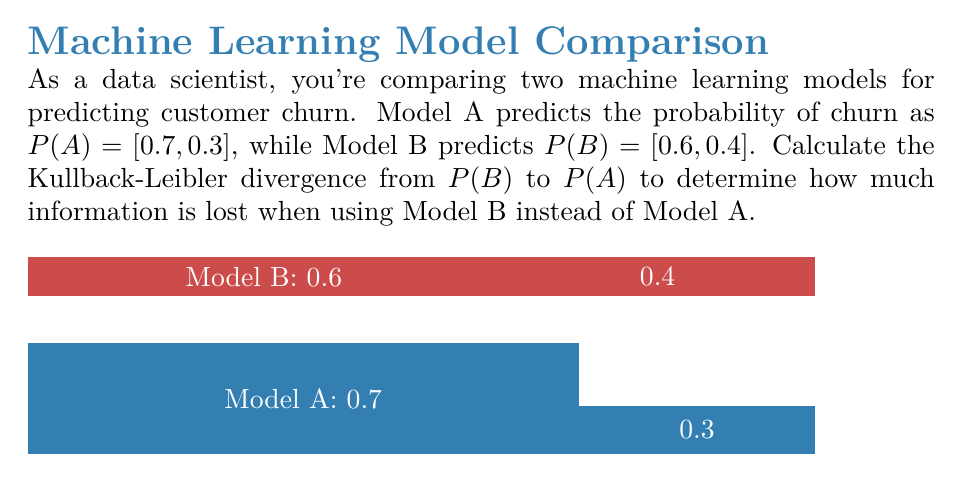Provide a solution to this math problem. To calculate the Kullback-Leibler (KL) divergence from P(B) to P(A), we'll use the formula:

$$ D_{KL}(P(A) || P(B)) = \sum_{i} P(A)_i \log(\frac{P(A)_i}{P(B)_i}) $$

Where $P(A)_i$ and $P(B)_i$ are the probabilities for each outcome i.

Step 1: Identify the probabilities
P(A) = [0.7, 0.3]
P(B) = [0.6, 0.4]

Step 2: Calculate each term in the sum
For i = 1:
$0.7 \log(\frac{0.7}{0.6}) = 0.7 \log(1.1667) = 0.7 \times 0.1542 = 0.1079$

For i = 2:
$0.3 \log(\frac{0.3}{0.4}) = 0.3 \log(0.75) = 0.3 \times (-0.2877) = -0.0863$

Step 3: Sum the terms
$D_{KL}(P(A) || P(B)) = 0.1079 + (-0.0863) = 0.0216$

Therefore, the Kullback-Leibler divergence from P(B) to P(A) is approximately 0.0216 bits.
Answer: 0.0216 bits 